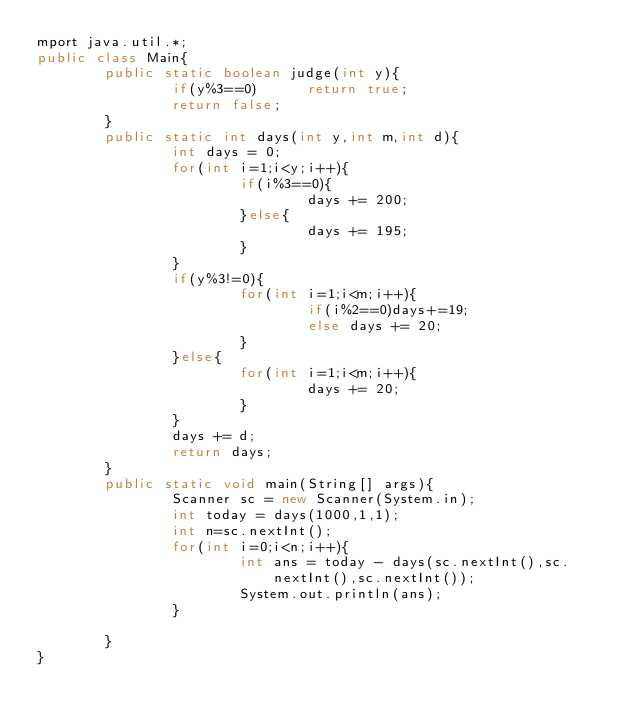<code> <loc_0><loc_0><loc_500><loc_500><_Java_>mport java.util.*;
public class Main{
        public static boolean judge(int y){
                if(y%3==0)      return true;
                return false;
        }
        public static int days(int y,int m,int d){
                int days = 0;
                for(int i=1;i<y;i++){
                        if(i%3==0){
                                days += 200;
                        }else{
                                days += 195;
                        }
                }
                if(y%3!=0){
                        for(int i=1;i<m;i++){
                                if(i%2==0)days+=19;
                                else days += 20;
                        }
                }else{
                        for(int i=1;i<m;i++){
                                days += 20;
                        }
                }
                days += d;
                return days;
        }
        public static void main(String[] args){
                Scanner sc = new Scanner(System.in);
                int today = days(1000,1,1);
                int n=sc.nextInt();
                for(int i=0;i<n;i++){
                        int ans = today - days(sc.nextInt(),sc.nextInt(),sc.nextInt());
                        System.out.println(ans);
                }

        }
}</code> 